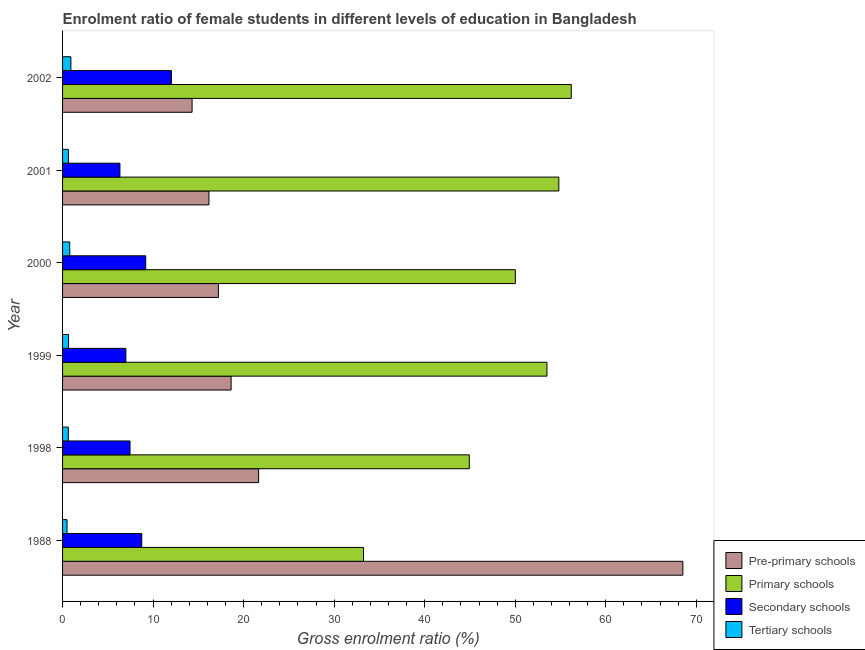How many different coloured bars are there?
Ensure brevity in your answer.  4. How many groups of bars are there?
Your answer should be very brief. 6. Are the number of bars per tick equal to the number of legend labels?
Provide a short and direct response. Yes. What is the label of the 1st group of bars from the top?
Offer a very short reply. 2002. In how many cases, is the number of bars for a given year not equal to the number of legend labels?
Make the answer very short. 0. What is the gross enrolment ratio(male) in secondary schools in 2002?
Give a very brief answer. 12.02. Across all years, what is the maximum gross enrolment ratio(male) in primary schools?
Your answer should be compact. 56.19. Across all years, what is the minimum gross enrolment ratio(male) in primary schools?
Ensure brevity in your answer.  33.24. In which year was the gross enrolment ratio(male) in pre-primary schools minimum?
Keep it short and to the point. 2002. What is the total gross enrolment ratio(male) in tertiary schools in the graph?
Make the answer very short. 4.15. What is the difference between the gross enrolment ratio(male) in secondary schools in 2000 and that in 2001?
Offer a terse response. 2.85. What is the difference between the gross enrolment ratio(male) in tertiary schools in 1988 and the gross enrolment ratio(male) in pre-primary schools in 1998?
Ensure brevity in your answer.  -21.16. What is the average gross enrolment ratio(male) in secondary schools per year?
Ensure brevity in your answer.  8.46. In the year 2000, what is the difference between the gross enrolment ratio(male) in secondary schools and gross enrolment ratio(male) in tertiary schools?
Provide a succinct answer. 8.39. What is the ratio of the gross enrolment ratio(male) in primary schools in 1988 to that in 1998?
Your answer should be very brief. 0.74. Is the gross enrolment ratio(male) in primary schools in 1999 less than that in 2002?
Keep it short and to the point. Yes. Is the difference between the gross enrolment ratio(male) in pre-primary schools in 1998 and 2000 greater than the difference between the gross enrolment ratio(male) in secondary schools in 1998 and 2000?
Make the answer very short. Yes. What is the difference between the highest and the second highest gross enrolment ratio(male) in tertiary schools?
Provide a succinct answer. 0.13. What is the difference between the highest and the lowest gross enrolment ratio(male) in tertiary schools?
Provide a short and direct response. 0.43. In how many years, is the gross enrolment ratio(male) in secondary schools greater than the average gross enrolment ratio(male) in secondary schools taken over all years?
Make the answer very short. 3. Is the sum of the gross enrolment ratio(male) in tertiary schools in 2000 and 2002 greater than the maximum gross enrolment ratio(male) in primary schools across all years?
Provide a short and direct response. No. Is it the case that in every year, the sum of the gross enrolment ratio(male) in tertiary schools and gross enrolment ratio(male) in pre-primary schools is greater than the sum of gross enrolment ratio(male) in secondary schools and gross enrolment ratio(male) in primary schools?
Offer a terse response. No. What does the 2nd bar from the top in 2002 represents?
Give a very brief answer. Secondary schools. What does the 1st bar from the bottom in 1988 represents?
Your answer should be very brief. Pre-primary schools. How many bars are there?
Provide a short and direct response. 24. Are all the bars in the graph horizontal?
Give a very brief answer. Yes. How many years are there in the graph?
Give a very brief answer. 6. What is the difference between two consecutive major ticks on the X-axis?
Provide a succinct answer. 10. Are the values on the major ticks of X-axis written in scientific E-notation?
Offer a terse response. No. Where does the legend appear in the graph?
Offer a terse response. Bottom right. How are the legend labels stacked?
Ensure brevity in your answer.  Vertical. What is the title of the graph?
Your response must be concise. Enrolment ratio of female students in different levels of education in Bangladesh. Does "Insurance services" appear as one of the legend labels in the graph?
Make the answer very short. No. What is the Gross enrolment ratio (%) of Pre-primary schools in 1988?
Make the answer very short. 68.52. What is the Gross enrolment ratio (%) in Primary schools in 1988?
Ensure brevity in your answer.  33.24. What is the Gross enrolment ratio (%) of Secondary schools in 1988?
Ensure brevity in your answer.  8.74. What is the Gross enrolment ratio (%) in Tertiary schools in 1988?
Give a very brief answer. 0.49. What is the Gross enrolment ratio (%) in Pre-primary schools in 1998?
Your answer should be compact. 21.66. What is the Gross enrolment ratio (%) in Primary schools in 1998?
Offer a terse response. 44.93. What is the Gross enrolment ratio (%) in Secondary schools in 1998?
Your answer should be compact. 7.45. What is the Gross enrolment ratio (%) in Tertiary schools in 1998?
Provide a short and direct response. 0.64. What is the Gross enrolment ratio (%) of Pre-primary schools in 1999?
Give a very brief answer. 18.62. What is the Gross enrolment ratio (%) of Primary schools in 1999?
Provide a short and direct response. 53.5. What is the Gross enrolment ratio (%) of Secondary schools in 1999?
Offer a very short reply. 6.99. What is the Gross enrolment ratio (%) in Tertiary schools in 1999?
Your response must be concise. 0.66. What is the Gross enrolment ratio (%) of Pre-primary schools in 2000?
Make the answer very short. 17.21. What is the Gross enrolment ratio (%) in Primary schools in 2000?
Make the answer very short. 50.01. What is the Gross enrolment ratio (%) in Secondary schools in 2000?
Provide a short and direct response. 9.18. What is the Gross enrolment ratio (%) in Tertiary schools in 2000?
Provide a short and direct response. 0.79. What is the Gross enrolment ratio (%) of Pre-primary schools in 2001?
Your answer should be very brief. 16.17. What is the Gross enrolment ratio (%) in Primary schools in 2001?
Provide a succinct answer. 54.82. What is the Gross enrolment ratio (%) of Secondary schools in 2001?
Give a very brief answer. 6.34. What is the Gross enrolment ratio (%) in Tertiary schools in 2001?
Offer a terse response. 0.65. What is the Gross enrolment ratio (%) of Pre-primary schools in 2002?
Offer a terse response. 14.31. What is the Gross enrolment ratio (%) in Primary schools in 2002?
Ensure brevity in your answer.  56.19. What is the Gross enrolment ratio (%) of Secondary schools in 2002?
Keep it short and to the point. 12.02. What is the Gross enrolment ratio (%) of Tertiary schools in 2002?
Your answer should be very brief. 0.92. Across all years, what is the maximum Gross enrolment ratio (%) in Pre-primary schools?
Make the answer very short. 68.52. Across all years, what is the maximum Gross enrolment ratio (%) in Primary schools?
Offer a very short reply. 56.19. Across all years, what is the maximum Gross enrolment ratio (%) of Secondary schools?
Ensure brevity in your answer.  12.02. Across all years, what is the maximum Gross enrolment ratio (%) in Tertiary schools?
Give a very brief answer. 0.92. Across all years, what is the minimum Gross enrolment ratio (%) of Pre-primary schools?
Keep it short and to the point. 14.31. Across all years, what is the minimum Gross enrolment ratio (%) of Primary schools?
Keep it short and to the point. 33.24. Across all years, what is the minimum Gross enrolment ratio (%) of Secondary schools?
Offer a terse response. 6.34. Across all years, what is the minimum Gross enrolment ratio (%) of Tertiary schools?
Give a very brief answer. 0.49. What is the total Gross enrolment ratio (%) in Pre-primary schools in the graph?
Keep it short and to the point. 156.48. What is the total Gross enrolment ratio (%) in Primary schools in the graph?
Provide a succinct answer. 292.7. What is the total Gross enrolment ratio (%) in Secondary schools in the graph?
Give a very brief answer. 50.73. What is the total Gross enrolment ratio (%) in Tertiary schools in the graph?
Offer a very short reply. 4.15. What is the difference between the Gross enrolment ratio (%) in Pre-primary schools in 1988 and that in 1998?
Provide a short and direct response. 46.86. What is the difference between the Gross enrolment ratio (%) of Primary schools in 1988 and that in 1998?
Your answer should be compact. -11.69. What is the difference between the Gross enrolment ratio (%) in Secondary schools in 1988 and that in 1998?
Your answer should be very brief. 1.29. What is the difference between the Gross enrolment ratio (%) in Tertiary schools in 1988 and that in 1998?
Offer a very short reply. -0.14. What is the difference between the Gross enrolment ratio (%) of Pre-primary schools in 1988 and that in 1999?
Give a very brief answer. 49.9. What is the difference between the Gross enrolment ratio (%) in Primary schools in 1988 and that in 1999?
Provide a short and direct response. -20.26. What is the difference between the Gross enrolment ratio (%) of Secondary schools in 1988 and that in 1999?
Keep it short and to the point. 1.75. What is the difference between the Gross enrolment ratio (%) in Tertiary schools in 1988 and that in 1999?
Your answer should be compact. -0.17. What is the difference between the Gross enrolment ratio (%) of Pre-primary schools in 1988 and that in 2000?
Offer a terse response. 51.31. What is the difference between the Gross enrolment ratio (%) in Primary schools in 1988 and that in 2000?
Your response must be concise. -16.77. What is the difference between the Gross enrolment ratio (%) of Secondary schools in 1988 and that in 2000?
Keep it short and to the point. -0.44. What is the difference between the Gross enrolment ratio (%) of Tertiary schools in 1988 and that in 2000?
Your answer should be compact. -0.3. What is the difference between the Gross enrolment ratio (%) of Pre-primary schools in 1988 and that in 2001?
Ensure brevity in your answer.  52.35. What is the difference between the Gross enrolment ratio (%) in Primary schools in 1988 and that in 2001?
Make the answer very short. -21.57. What is the difference between the Gross enrolment ratio (%) in Secondary schools in 1988 and that in 2001?
Keep it short and to the point. 2.41. What is the difference between the Gross enrolment ratio (%) in Tertiary schools in 1988 and that in 2001?
Offer a very short reply. -0.15. What is the difference between the Gross enrolment ratio (%) of Pre-primary schools in 1988 and that in 2002?
Ensure brevity in your answer.  54.21. What is the difference between the Gross enrolment ratio (%) in Primary schools in 1988 and that in 2002?
Your answer should be very brief. -22.95. What is the difference between the Gross enrolment ratio (%) of Secondary schools in 1988 and that in 2002?
Offer a very short reply. -3.28. What is the difference between the Gross enrolment ratio (%) in Tertiary schools in 1988 and that in 2002?
Keep it short and to the point. -0.43. What is the difference between the Gross enrolment ratio (%) of Pre-primary schools in 1998 and that in 1999?
Offer a terse response. 3.04. What is the difference between the Gross enrolment ratio (%) of Primary schools in 1998 and that in 1999?
Provide a succinct answer. -8.57. What is the difference between the Gross enrolment ratio (%) of Secondary schools in 1998 and that in 1999?
Make the answer very short. 0.46. What is the difference between the Gross enrolment ratio (%) of Tertiary schools in 1998 and that in 1999?
Offer a very short reply. -0.03. What is the difference between the Gross enrolment ratio (%) in Pre-primary schools in 1998 and that in 2000?
Keep it short and to the point. 4.44. What is the difference between the Gross enrolment ratio (%) of Primary schools in 1998 and that in 2000?
Offer a terse response. -5.08. What is the difference between the Gross enrolment ratio (%) of Secondary schools in 1998 and that in 2000?
Make the answer very short. -1.73. What is the difference between the Gross enrolment ratio (%) of Tertiary schools in 1998 and that in 2000?
Offer a terse response. -0.16. What is the difference between the Gross enrolment ratio (%) of Pre-primary schools in 1998 and that in 2001?
Keep it short and to the point. 5.49. What is the difference between the Gross enrolment ratio (%) of Primary schools in 1998 and that in 2001?
Offer a very short reply. -9.89. What is the difference between the Gross enrolment ratio (%) of Secondary schools in 1998 and that in 2001?
Offer a terse response. 1.12. What is the difference between the Gross enrolment ratio (%) of Tertiary schools in 1998 and that in 2001?
Make the answer very short. -0.01. What is the difference between the Gross enrolment ratio (%) in Pre-primary schools in 1998 and that in 2002?
Your response must be concise. 7.35. What is the difference between the Gross enrolment ratio (%) in Primary schools in 1998 and that in 2002?
Keep it short and to the point. -11.26. What is the difference between the Gross enrolment ratio (%) of Secondary schools in 1998 and that in 2002?
Give a very brief answer. -4.57. What is the difference between the Gross enrolment ratio (%) of Tertiary schools in 1998 and that in 2002?
Your answer should be very brief. -0.28. What is the difference between the Gross enrolment ratio (%) in Pre-primary schools in 1999 and that in 2000?
Your answer should be very brief. 1.4. What is the difference between the Gross enrolment ratio (%) of Primary schools in 1999 and that in 2000?
Keep it short and to the point. 3.49. What is the difference between the Gross enrolment ratio (%) in Secondary schools in 1999 and that in 2000?
Ensure brevity in your answer.  -2.19. What is the difference between the Gross enrolment ratio (%) in Tertiary schools in 1999 and that in 2000?
Provide a succinct answer. -0.13. What is the difference between the Gross enrolment ratio (%) in Pre-primary schools in 1999 and that in 2001?
Make the answer very short. 2.45. What is the difference between the Gross enrolment ratio (%) of Primary schools in 1999 and that in 2001?
Your answer should be compact. -1.31. What is the difference between the Gross enrolment ratio (%) in Secondary schools in 1999 and that in 2001?
Give a very brief answer. 0.65. What is the difference between the Gross enrolment ratio (%) in Tertiary schools in 1999 and that in 2001?
Keep it short and to the point. 0.02. What is the difference between the Gross enrolment ratio (%) in Pre-primary schools in 1999 and that in 2002?
Offer a very short reply. 4.31. What is the difference between the Gross enrolment ratio (%) in Primary schools in 1999 and that in 2002?
Your answer should be very brief. -2.69. What is the difference between the Gross enrolment ratio (%) of Secondary schools in 1999 and that in 2002?
Provide a succinct answer. -5.03. What is the difference between the Gross enrolment ratio (%) of Tertiary schools in 1999 and that in 2002?
Offer a terse response. -0.26. What is the difference between the Gross enrolment ratio (%) in Pre-primary schools in 2000 and that in 2001?
Provide a succinct answer. 1.04. What is the difference between the Gross enrolment ratio (%) of Primary schools in 2000 and that in 2001?
Ensure brevity in your answer.  -4.8. What is the difference between the Gross enrolment ratio (%) in Secondary schools in 2000 and that in 2001?
Provide a short and direct response. 2.85. What is the difference between the Gross enrolment ratio (%) of Tertiary schools in 2000 and that in 2001?
Make the answer very short. 0.15. What is the difference between the Gross enrolment ratio (%) of Pre-primary schools in 2000 and that in 2002?
Your response must be concise. 2.91. What is the difference between the Gross enrolment ratio (%) in Primary schools in 2000 and that in 2002?
Offer a very short reply. -6.18. What is the difference between the Gross enrolment ratio (%) of Secondary schools in 2000 and that in 2002?
Your answer should be very brief. -2.84. What is the difference between the Gross enrolment ratio (%) of Tertiary schools in 2000 and that in 2002?
Your answer should be compact. -0.13. What is the difference between the Gross enrolment ratio (%) of Pre-primary schools in 2001 and that in 2002?
Your response must be concise. 1.86. What is the difference between the Gross enrolment ratio (%) of Primary schools in 2001 and that in 2002?
Give a very brief answer. -1.37. What is the difference between the Gross enrolment ratio (%) in Secondary schools in 2001 and that in 2002?
Keep it short and to the point. -5.69. What is the difference between the Gross enrolment ratio (%) in Tertiary schools in 2001 and that in 2002?
Your answer should be very brief. -0.27. What is the difference between the Gross enrolment ratio (%) of Pre-primary schools in 1988 and the Gross enrolment ratio (%) of Primary schools in 1998?
Ensure brevity in your answer.  23.59. What is the difference between the Gross enrolment ratio (%) of Pre-primary schools in 1988 and the Gross enrolment ratio (%) of Secondary schools in 1998?
Keep it short and to the point. 61.07. What is the difference between the Gross enrolment ratio (%) in Pre-primary schools in 1988 and the Gross enrolment ratio (%) in Tertiary schools in 1998?
Provide a succinct answer. 67.88. What is the difference between the Gross enrolment ratio (%) in Primary schools in 1988 and the Gross enrolment ratio (%) in Secondary schools in 1998?
Make the answer very short. 25.79. What is the difference between the Gross enrolment ratio (%) in Primary schools in 1988 and the Gross enrolment ratio (%) in Tertiary schools in 1998?
Offer a very short reply. 32.61. What is the difference between the Gross enrolment ratio (%) in Secondary schools in 1988 and the Gross enrolment ratio (%) in Tertiary schools in 1998?
Ensure brevity in your answer.  8.11. What is the difference between the Gross enrolment ratio (%) in Pre-primary schools in 1988 and the Gross enrolment ratio (%) in Primary schools in 1999?
Make the answer very short. 15.02. What is the difference between the Gross enrolment ratio (%) in Pre-primary schools in 1988 and the Gross enrolment ratio (%) in Secondary schools in 1999?
Provide a short and direct response. 61.53. What is the difference between the Gross enrolment ratio (%) in Pre-primary schools in 1988 and the Gross enrolment ratio (%) in Tertiary schools in 1999?
Offer a terse response. 67.86. What is the difference between the Gross enrolment ratio (%) in Primary schools in 1988 and the Gross enrolment ratio (%) in Secondary schools in 1999?
Give a very brief answer. 26.25. What is the difference between the Gross enrolment ratio (%) of Primary schools in 1988 and the Gross enrolment ratio (%) of Tertiary schools in 1999?
Ensure brevity in your answer.  32.58. What is the difference between the Gross enrolment ratio (%) of Secondary schools in 1988 and the Gross enrolment ratio (%) of Tertiary schools in 1999?
Offer a terse response. 8.08. What is the difference between the Gross enrolment ratio (%) in Pre-primary schools in 1988 and the Gross enrolment ratio (%) in Primary schools in 2000?
Keep it short and to the point. 18.51. What is the difference between the Gross enrolment ratio (%) of Pre-primary schools in 1988 and the Gross enrolment ratio (%) of Secondary schools in 2000?
Provide a short and direct response. 59.34. What is the difference between the Gross enrolment ratio (%) of Pre-primary schools in 1988 and the Gross enrolment ratio (%) of Tertiary schools in 2000?
Offer a terse response. 67.73. What is the difference between the Gross enrolment ratio (%) in Primary schools in 1988 and the Gross enrolment ratio (%) in Secondary schools in 2000?
Provide a short and direct response. 24.06. What is the difference between the Gross enrolment ratio (%) in Primary schools in 1988 and the Gross enrolment ratio (%) in Tertiary schools in 2000?
Give a very brief answer. 32.45. What is the difference between the Gross enrolment ratio (%) of Secondary schools in 1988 and the Gross enrolment ratio (%) of Tertiary schools in 2000?
Your answer should be compact. 7.95. What is the difference between the Gross enrolment ratio (%) in Pre-primary schools in 1988 and the Gross enrolment ratio (%) in Primary schools in 2001?
Keep it short and to the point. 13.7. What is the difference between the Gross enrolment ratio (%) in Pre-primary schools in 1988 and the Gross enrolment ratio (%) in Secondary schools in 2001?
Your answer should be very brief. 62.18. What is the difference between the Gross enrolment ratio (%) in Pre-primary schools in 1988 and the Gross enrolment ratio (%) in Tertiary schools in 2001?
Ensure brevity in your answer.  67.87. What is the difference between the Gross enrolment ratio (%) of Primary schools in 1988 and the Gross enrolment ratio (%) of Secondary schools in 2001?
Provide a succinct answer. 26.91. What is the difference between the Gross enrolment ratio (%) in Primary schools in 1988 and the Gross enrolment ratio (%) in Tertiary schools in 2001?
Offer a very short reply. 32.6. What is the difference between the Gross enrolment ratio (%) in Secondary schools in 1988 and the Gross enrolment ratio (%) in Tertiary schools in 2001?
Your response must be concise. 8.1. What is the difference between the Gross enrolment ratio (%) in Pre-primary schools in 1988 and the Gross enrolment ratio (%) in Primary schools in 2002?
Your answer should be compact. 12.33. What is the difference between the Gross enrolment ratio (%) in Pre-primary schools in 1988 and the Gross enrolment ratio (%) in Secondary schools in 2002?
Make the answer very short. 56.5. What is the difference between the Gross enrolment ratio (%) of Pre-primary schools in 1988 and the Gross enrolment ratio (%) of Tertiary schools in 2002?
Offer a very short reply. 67.6. What is the difference between the Gross enrolment ratio (%) in Primary schools in 1988 and the Gross enrolment ratio (%) in Secondary schools in 2002?
Ensure brevity in your answer.  21.22. What is the difference between the Gross enrolment ratio (%) of Primary schools in 1988 and the Gross enrolment ratio (%) of Tertiary schools in 2002?
Make the answer very short. 32.32. What is the difference between the Gross enrolment ratio (%) of Secondary schools in 1988 and the Gross enrolment ratio (%) of Tertiary schools in 2002?
Provide a short and direct response. 7.82. What is the difference between the Gross enrolment ratio (%) in Pre-primary schools in 1998 and the Gross enrolment ratio (%) in Primary schools in 1999?
Your answer should be compact. -31.85. What is the difference between the Gross enrolment ratio (%) of Pre-primary schools in 1998 and the Gross enrolment ratio (%) of Secondary schools in 1999?
Your answer should be very brief. 14.67. What is the difference between the Gross enrolment ratio (%) in Pre-primary schools in 1998 and the Gross enrolment ratio (%) in Tertiary schools in 1999?
Provide a short and direct response. 20.99. What is the difference between the Gross enrolment ratio (%) of Primary schools in 1998 and the Gross enrolment ratio (%) of Secondary schools in 1999?
Provide a succinct answer. 37.94. What is the difference between the Gross enrolment ratio (%) of Primary schools in 1998 and the Gross enrolment ratio (%) of Tertiary schools in 1999?
Make the answer very short. 44.27. What is the difference between the Gross enrolment ratio (%) of Secondary schools in 1998 and the Gross enrolment ratio (%) of Tertiary schools in 1999?
Your response must be concise. 6.79. What is the difference between the Gross enrolment ratio (%) in Pre-primary schools in 1998 and the Gross enrolment ratio (%) in Primary schools in 2000?
Provide a short and direct response. -28.36. What is the difference between the Gross enrolment ratio (%) in Pre-primary schools in 1998 and the Gross enrolment ratio (%) in Secondary schools in 2000?
Ensure brevity in your answer.  12.47. What is the difference between the Gross enrolment ratio (%) of Pre-primary schools in 1998 and the Gross enrolment ratio (%) of Tertiary schools in 2000?
Ensure brevity in your answer.  20.87. What is the difference between the Gross enrolment ratio (%) in Primary schools in 1998 and the Gross enrolment ratio (%) in Secondary schools in 2000?
Give a very brief answer. 35.75. What is the difference between the Gross enrolment ratio (%) of Primary schools in 1998 and the Gross enrolment ratio (%) of Tertiary schools in 2000?
Ensure brevity in your answer.  44.14. What is the difference between the Gross enrolment ratio (%) in Secondary schools in 1998 and the Gross enrolment ratio (%) in Tertiary schools in 2000?
Give a very brief answer. 6.66. What is the difference between the Gross enrolment ratio (%) in Pre-primary schools in 1998 and the Gross enrolment ratio (%) in Primary schools in 2001?
Ensure brevity in your answer.  -33.16. What is the difference between the Gross enrolment ratio (%) of Pre-primary schools in 1998 and the Gross enrolment ratio (%) of Secondary schools in 2001?
Your answer should be compact. 15.32. What is the difference between the Gross enrolment ratio (%) of Pre-primary schools in 1998 and the Gross enrolment ratio (%) of Tertiary schools in 2001?
Your response must be concise. 21.01. What is the difference between the Gross enrolment ratio (%) of Primary schools in 1998 and the Gross enrolment ratio (%) of Secondary schools in 2001?
Your response must be concise. 38.59. What is the difference between the Gross enrolment ratio (%) in Primary schools in 1998 and the Gross enrolment ratio (%) in Tertiary schools in 2001?
Provide a short and direct response. 44.28. What is the difference between the Gross enrolment ratio (%) in Secondary schools in 1998 and the Gross enrolment ratio (%) in Tertiary schools in 2001?
Offer a terse response. 6.81. What is the difference between the Gross enrolment ratio (%) of Pre-primary schools in 1998 and the Gross enrolment ratio (%) of Primary schools in 2002?
Ensure brevity in your answer.  -34.54. What is the difference between the Gross enrolment ratio (%) of Pre-primary schools in 1998 and the Gross enrolment ratio (%) of Secondary schools in 2002?
Your response must be concise. 9.63. What is the difference between the Gross enrolment ratio (%) in Pre-primary schools in 1998 and the Gross enrolment ratio (%) in Tertiary schools in 2002?
Give a very brief answer. 20.74. What is the difference between the Gross enrolment ratio (%) in Primary schools in 1998 and the Gross enrolment ratio (%) in Secondary schools in 2002?
Keep it short and to the point. 32.91. What is the difference between the Gross enrolment ratio (%) in Primary schools in 1998 and the Gross enrolment ratio (%) in Tertiary schools in 2002?
Keep it short and to the point. 44.01. What is the difference between the Gross enrolment ratio (%) in Secondary schools in 1998 and the Gross enrolment ratio (%) in Tertiary schools in 2002?
Make the answer very short. 6.53. What is the difference between the Gross enrolment ratio (%) of Pre-primary schools in 1999 and the Gross enrolment ratio (%) of Primary schools in 2000?
Your answer should be compact. -31.4. What is the difference between the Gross enrolment ratio (%) in Pre-primary schools in 1999 and the Gross enrolment ratio (%) in Secondary schools in 2000?
Make the answer very short. 9.43. What is the difference between the Gross enrolment ratio (%) in Pre-primary schools in 1999 and the Gross enrolment ratio (%) in Tertiary schools in 2000?
Offer a terse response. 17.83. What is the difference between the Gross enrolment ratio (%) of Primary schools in 1999 and the Gross enrolment ratio (%) of Secondary schools in 2000?
Provide a succinct answer. 44.32. What is the difference between the Gross enrolment ratio (%) of Primary schools in 1999 and the Gross enrolment ratio (%) of Tertiary schools in 2000?
Make the answer very short. 52.71. What is the difference between the Gross enrolment ratio (%) of Secondary schools in 1999 and the Gross enrolment ratio (%) of Tertiary schools in 2000?
Provide a succinct answer. 6.2. What is the difference between the Gross enrolment ratio (%) in Pre-primary schools in 1999 and the Gross enrolment ratio (%) in Primary schools in 2001?
Offer a very short reply. -36.2. What is the difference between the Gross enrolment ratio (%) of Pre-primary schools in 1999 and the Gross enrolment ratio (%) of Secondary schools in 2001?
Give a very brief answer. 12.28. What is the difference between the Gross enrolment ratio (%) of Pre-primary schools in 1999 and the Gross enrolment ratio (%) of Tertiary schools in 2001?
Offer a terse response. 17.97. What is the difference between the Gross enrolment ratio (%) in Primary schools in 1999 and the Gross enrolment ratio (%) in Secondary schools in 2001?
Your answer should be very brief. 47.17. What is the difference between the Gross enrolment ratio (%) of Primary schools in 1999 and the Gross enrolment ratio (%) of Tertiary schools in 2001?
Keep it short and to the point. 52.86. What is the difference between the Gross enrolment ratio (%) in Secondary schools in 1999 and the Gross enrolment ratio (%) in Tertiary schools in 2001?
Offer a terse response. 6.34. What is the difference between the Gross enrolment ratio (%) in Pre-primary schools in 1999 and the Gross enrolment ratio (%) in Primary schools in 2002?
Keep it short and to the point. -37.57. What is the difference between the Gross enrolment ratio (%) of Pre-primary schools in 1999 and the Gross enrolment ratio (%) of Secondary schools in 2002?
Your answer should be very brief. 6.6. What is the difference between the Gross enrolment ratio (%) in Pre-primary schools in 1999 and the Gross enrolment ratio (%) in Tertiary schools in 2002?
Make the answer very short. 17.7. What is the difference between the Gross enrolment ratio (%) of Primary schools in 1999 and the Gross enrolment ratio (%) of Secondary schools in 2002?
Offer a terse response. 41.48. What is the difference between the Gross enrolment ratio (%) of Primary schools in 1999 and the Gross enrolment ratio (%) of Tertiary schools in 2002?
Keep it short and to the point. 52.58. What is the difference between the Gross enrolment ratio (%) in Secondary schools in 1999 and the Gross enrolment ratio (%) in Tertiary schools in 2002?
Offer a terse response. 6.07. What is the difference between the Gross enrolment ratio (%) in Pre-primary schools in 2000 and the Gross enrolment ratio (%) in Primary schools in 2001?
Offer a terse response. -37.6. What is the difference between the Gross enrolment ratio (%) in Pre-primary schools in 2000 and the Gross enrolment ratio (%) in Secondary schools in 2001?
Keep it short and to the point. 10.88. What is the difference between the Gross enrolment ratio (%) in Pre-primary schools in 2000 and the Gross enrolment ratio (%) in Tertiary schools in 2001?
Provide a short and direct response. 16.57. What is the difference between the Gross enrolment ratio (%) in Primary schools in 2000 and the Gross enrolment ratio (%) in Secondary schools in 2001?
Offer a terse response. 43.68. What is the difference between the Gross enrolment ratio (%) of Primary schools in 2000 and the Gross enrolment ratio (%) of Tertiary schools in 2001?
Your answer should be very brief. 49.37. What is the difference between the Gross enrolment ratio (%) of Secondary schools in 2000 and the Gross enrolment ratio (%) of Tertiary schools in 2001?
Provide a short and direct response. 8.54. What is the difference between the Gross enrolment ratio (%) in Pre-primary schools in 2000 and the Gross enrolment ratio (%) in Primary schools in 2002?
Ensure brevity in your answer.  -38.98. What is the difference between the Gross enrolment ratio (%) in Pre-primary schools in 2000 and the Gross enrolment ratio (%) in Secondary schools in 2002?
Offer a very short reply. 5.19. What is the difference between the Gross enrolment ratio (%) in Pre-primary schools in 2000 and the Gross enrolment ratio (%) in Tertiary schools in 2002?
Provide a succinct answer. 16.29. What is the difference between the Gross enrolment ratio (%) in Primary schools in 2000 and the Gross enrolment ratio (%) in Secondary schools in 2002?
Keep it short and to the point. 37.99. What is the difference between the Gross enrolment ratio (%) in Primary schools in 2000 and the Gross enrolment ratio (%) in Tertiary schools in 2002?
Your answer should be very brief. 49.09. What is the difference between the Gross enrolment ratio (%) of Secondary schools in 2000 and the Gross enrolment ratio (%) of Tertiary schools in 2002?
Your response must be concise. 8.26. What is the difference between the Gross enrolment ratio (%) of Pre-primary schools in 2001 and the Gross enrolment ratio (%) of Primary schools in 2002?
Ensure brevity in your answer.  -40.02. What is the difference between the Gross enrolment ratio (%) in Pre-primary schools in 2001 and the Gross enrolment ratio (%) in Secondary schools in 2002?
Give a very brief answer. 4.15. What is the difference between the Gross enrolment ratio (%) in Pre-primary schools in 2001 and the Gross enrolment ratio (%) in Tertiary schools in 2002?
Give a very brief answer. 15.25. What is the difference between the Gross enrolment ratio (%) of Primary schools in 2001 and the Gross enrolment ratio (%) of Secondary schools in 2002?
Your answer should be very brief. 42.79. What is the difference between the Gross enrolment ratio (%) in Primary schools in 2001 and the Gross enrolment ratio (%) in Tertiary schools in 2002?
Provide a short and direct response. 53.9. What is the difference between the Gross enrolment ratio (%) in Secondary schools in 2001 and the Gross enrolment ratio (%) in Tertiary schools in 2002?
Offer a very short reply. 5.42. What is the average Gross enrolment ratio (%) in Pre-primary schools per year?
Offer a terse response. 26.08. What is the average Gross enrolment ratio (%) in Primary schools per year?
Your answer should be very brief. 48.78. What is the average Gross enrolment ratio (%) of Secondary schools per year?
Offer a terse response. 8.45. What is the average Gross enrolment ratio (%) of Tertiary schools per year?
Your answer should be compact. 0.69. In the year 1988, what is the difference between the Gross enrolment ratio (%) in Pre-primary schools and Gross enrolment ratio (%) in Primary schools?
Offer a very short reply. 35.28. In the year 1988, what is the difference between the Gross enrolment ratio (%) of Pre-primary schools and Gross enrolment ratio (%) of Secondary schools?
Your answer should be compact. 59.78. In the year 1988, what is the difference between the Gross enrolment ratio (%) of Pre-primary schools and Gross enrolment ratio (%) of Tertiary schools?
Your response must be concise. 68.03. In the year 1988, what is the difference between the Gross enrolment ratio (%) in Primary schools and Gross enrolment ratio (%) in Secondary schools?
Provide a succinct answer. 24.5. In the year 1988, what is the difference between the Gross enrolment ratio (%) in Primary schools and Gross enrolment ratio (%) in Tertiary schools?
Provide a short and direct response. 32.75. In the year 1988, what is the difference between the Gross enrolment ratio (%) of Secondary schools and Gross enrolment ratio (%) of Tertiary schools?
Offer a terse response. 8.25. In the year 1998, what is the difference between the Gross enrolment ratio (%) of Pre-primary schools and Gross enrolment ratio (%) of Primary schools?
Keep it short and to the point. -23.27. In the year 1998, what is the difference between the Gross enrolment ratio (%) in Pre-primary schools and Gross enrolment ratio (%) in Secondary schools?
Your answer should be compact. 14.2. In the year 1998, what is the difference between the Gross enrolment ratio (%) in Pre-primary schools and Gross enrolment ratio (%) in Tertiary schools?
Offer a terse response. 21.02. In the year 1998, what is the difference between the Gross enrolment ratio (%) of Primary schools and Gross enrolment ratio (%) of Secondary schools?
Provide a short and direct response. 37.48. In the year 1998, what is the difference between the Gross enrolment ratio (%) in Primary schools and Gross enrolment ratio (%) in Tertiary schools?
Your answer should be very brief. 44.29. In the year 1998, what is the difference between the Gross enrolment ratio (%) in Secondary schools and Gross enrolment ratio (%) in Tertiary schools?
Offer a very short reply. 6.82. In the year 1999, what is the difference between the Gross enrolment ratio (%) of Pre-primary schools and Gross enrolment ratio (%) of Primary schools?
Keep it short and to the point. -34.88. In the year 1999, what is the difference between the Gross enrolment ratio (%) of Pre-primary schools and Gross enrolment ratio (%) of Secondary schools?
Ensure brevity in your answer.  11.63. In the year 1999, what is the difference between the Gross enrolment ratio (%) in Pre-primary schools and Gross enrolment ratio (%) in Tertiary schools?
Offer a terse response. 17.96. In the year 1999, what is the difference between the Gross enrolment ratio (%) of Primary schools and Gross enrolment ratio (%) of Secondary schools?
Your answer should be very brief. 46.51. In the year 1999, what is the difference between the Gross enrolment ratio (%) of Primary schools and Gross enrolment ratio (%) of Tertiary schools?
Offer a terse response. 52.84. In the year 1999, what is the difference between the Gross enrolment ratio (%) of Secondary schools and Gross enrolment ratio (%) of Tertiary schools?
Offer a terse response. 6.33. In the year 2000, what is the difference between the Gross enrolment ratio (%) of Pre-primary schools and Gross enrolment ratio (%) of Primary schools?
Your answer should be very brief. -32.8. In the year 2000, what is the difference between the Gross enrolment ratio (%) in Pre-primary schools and Gross enrolment ratio (%) in Secondary schools?
Your answer should be compact. 8.03. In the year 2000, what is the difference between the Gross enrolment ratio (%) of Pre-primary schools and Gross enrolment ratio (%) of Tertiary schools?
Provide a short and direct response. 16.42. In the year 2000, what is the difference between the Gross enrolment ratio (%) of Primary schools and Gross enrolment ratio (%) of Secondary schools?
Your answer should be very brief. 40.83. In the year 2000, what is the difference between the Gross enrolment ratio (%) in Primary schools and Gross enrolment ratio (%) in Tertiary schools?
Your response must be concise. 49.22. In the year 2000, what is the difference between the Gross enrolment ratio (%) in Secondary schools and Gross enrolment ratio (%) in Tertiary schools?
Keep it short and to the point. 8.39. In the year 2001, what is the difference between the Gross enrolment ratio (%) of Pre-primary schools and Gross enrolment ratio (%) of Primary schools?
Give a very brief answer. -38.65. In the year 2001, what is the difference between the Gross enrolment ratio (%) of Pre-primary schools and Gross enrolment ratio (%) of Secondary schools?
Your response must be concise. 9.83. In the year 2001, what is the difference between the Gross enrolment ratio (%) of Pre-primary schools and Gross enrolment ratio (%) of Tertiary schools?
Your answer should be very brief. 15.52. In the year 2001, what is the difference between the Gross enrolment ratio (%) of Primary schools and Gross enrolment ratio (%) of Secondary schools?
Make the answer very short. 48.48. In the year 2001, what is the difference between the Gross enrolment ratio (%) of Primary schools and Gross enrolment ratio (%) of Tertiary schools?
Offer a terse response. 54.17. In the year 2001, what is the difference between the Gross enrolment ratio (%) of Secondary schools and Gross enrolment ratio (%) of Tertiary schools?
Provide a short and direct response. 5.69. In the year 2002, what is the difference between the Gross enrolment ratio (%) in Pre-primary schools and Gross enrolment ratio (%) in Primary schools?
Give a very brief answer. -41.88. In the year 2002, what is the difference between the Gross enrolment ratio (%) of Pre-primary schools and Gross enrolment ratio (%) of Secondary schools?
Your answer should be very brief. 2.28. In the year 2002, what is the difference between the Gross enrolment ratio (%) in Pre-primary schools and Gross enrolment ratio (%) in Tertiary schools?
Provide a short and direct response. 13.39. In the year 2002, what is the difference between the Gross enrolment ratio (%) in Primary schools and Gross enrolment ratio (%) in Secondary schools?
Keep it short and to the point. 44.17. In the year 2002, what is the difference between the Gross enrolment ratio (%) in Primary schools and Gross enrolment ratio (%) in Tertiary schools?
Keep it short and to the point. 55.27. In the year 2002, what is the difference between the Gross enrolment ratio (%) of Secondary schools and Gross enrolment ratio (%) of Tertiary schools?
Provide a succinct answer. 11.1. What is the ratio of the Gross enrolment ratio (%) in Pre-primary schools in 1988 to that in 1998?
Provide a succinct answer. 3.16. What is the ratio of the Gross enrolment ratio (%) of Primary schools in 1988 to that in 1998?
Provide a succinct answer. 0.74. What is the ratio of the Gross enrolment ratio (%) of Secondary schools in 1988 to that in 1998?
Provide a short and direct response. 1.17. What is the ratio of the Gross enrolment ratio (%) in Tertiary schools in 1988 to that in 1998?
Offer a terse response. 0.78. What is the ratio of the Gross enrolment ratio (%) in Pre-primary schools in 1988 to that in 1999?
Give a very brief answer. 3.68. What is the ratio of the Gross enrolment ratio (%) in Primary schools in 1988 to that in 1999?
Keep it short and to the point. 0.62. What is the ratio of the Gross enrolment ratio (%) of Secondary schools in 1988 to that in 1999?
Your answer should be very brief. 1.25. What is the ratio of the Gross enrolment ratio (%) in Tertiary schools in 1988 to that in 1999?
Keep it short and to the point. 0.75. What is the ratio of the Gross enrolment ratio (%) in Pre-primary schools in 1988 to that in 2000?
Keep it short and to the point. 3.98. What is the ratio of the Gross enrolment ratio (%) in Primary schools in 1988 to that in 2000?
Your response must be concise. 0.66. What is the ratio of the Gross enrolment ratio (%) in Tertiary schools in 1988 to that in 2000?
Give a very brief answer. 0.62. What is the ratio of the Gross enrolment ratio (%) in Pre-primary schools in 1988 to that in 2001?
Offer a very short reply. 4.24. What is the ratio of the Gross enrolment ratio (%) of Primary schools in 1988 to that in 2001?
Keep it short and to the point. 0.61. What is the ratio of the Gross enrolment ratio (%) in Secondary schools in 1988 to that in 2001?
Keep it short and to the point. 1.38. What is the ratio of the Gross enrolment ratio (%) of Tertiary schools in 1988 to that in 2001?
Ensure brevity in your answer.  0.76. What is the ratio of the Gross enrolment ratio (%) of Pre-primary schools in 1988 to that in 2002?
Provide a short and direct response. 4.79. What is the ratio of the Gross enrolment ratio (%) in Primary schools in 1988 to that in 2002?
Provide a succinct answer. 0.59. What is the ratio of the Gross enrolment ratio (%) in Secondary schools in 1988 to that in 2002?
Give a very brief answer. 0.73. What is the ratio of the Gross enrolment ratio (%) in Tertiary schools in 1988 to that in 2002?
Give a very brief answer. 0.54. What is the ratio of the Gross enrolment ratio (%) of Pre-primary schools in 1998 to that in 1999?
Your response must be concise. 1.16. What is the ratio of the Gross enrolment ratio (%) in Primary schools in 1998 to that in 1999?
Your answer should be very brief. 0.84. What is the ratio of the Gross enrolment ratio (%) in Secondary schools in 1998 to that in 1999?
Keep it short and to the point. 1.07. What is the ratio of the Gross enrolment ratio (%) in Tertiary schools in 1998 to that in 1999?
Your response must be concise. 0.96. What is the ratio of the Gross enrolment ratio (%) of Pre-primary schools in 1998 to that in 2000?
Offer a very short reply. 1.26. What is the ratio of the Gross enrolment ratio (%) of Primary schools in 1998 to that in 2000?
Ensure brevity in your answer.  0.9. What is the ratio of the Gross enrolment ratio (%) of Secondary schools in 1998 to that in 2000?
Make the answer very short. 0.81. What is the ratio of the Gross enrolment ratio (%) of Tertiary schools in 1998 to that in 2000?
Your answer should be compact. 0.8. What is the ratio of the Gross enrolment ratio (%) in Pre-primary schools in 1998 to that in 2001?
Give a very brief answer. 1.34. What is the ratio of the Gross enrolment ratio (%) of Primary schools in 1998 to that in 2001?
Give a very brief answer. 0.82. What is the ratio of the Gross enrolment ratio (%) of Secondary schools in 1998 to that in 2001?
Your answer should be very brief. 1.18. What is the ratio of the Gross enrolment ratio (%) in Tertiary schools in 1998 to that in 2001?
Make the answer very short. 0.98. What is the ratio of the Gross enrolment ratio (%) of Pre-primary schools in 1998 to that in 2002?
Keep it short and to the point. 1.51. What is the ratio of the Gross enrolment ratio (%) of Primary schools in 1998 to that in 2002?
Keep it short and to the point. 0.8. What is the ratio of the Gross enrolment ratio (%) in Secondary schools in 1998 to that in 2002?
Keep it short and to the point. 0.62. What is the ratio of the Gross enrolment ratio (%) in Tertiary schools in 1998 to that in 2002?
Offer a terse response. 0.69. What is the ratio of the Gross enrolment ratio (%) in Pre-primary schools in 1999 to that in 2000?
Make the answer very short. 1.08. What is the ratio of the Gross enrolment ratio (%) of Primary schools in 1999 to that in 2000?
Offer a terse response. 1.07. What is the ratio of the Gross enrolment ratio (%) of Secondary schools in 1999 to that in 2000?
Offer a very short reply. 0.76. What is the ratio of the Gross enrolment ratio (%) of Tertiary schools in 1999 to that in 2000?
Keep it short and to the point. 0.84. What is the ratio of the Gross enrolment ratio (%) of Pre-primary schools in 1999 to that in 2001?
Provide a short and direct response. 1.15. What is the ratio of the Gross enrolment ratio (%) in Primary schools in 1999 to that in 2001?
Give a very brief answer. 0.98. What is the ratio of the Gross enrolment ratio (%) in Secondary schools in 1999 to that in 2001?
Provide a short and direct response. 1.1. What is the ratio of the Gross enrolment ratio (%) in Tertiary schools in 1999 to that in 2001?
Provide a succinct answer. 1.03. What is the ratio of the Gross enrolment ratio (%) in Pre-primary schools in 1999 to that in 2002?
Ensure brevity in your answer.  1.3. What is the ratio of the Gross enrolment ratio (%) of Primary schools in 1999 to that in 2002?
Keep it short and to the point. 0.95. What is the ratio of the Gross enrolment ratio (%) in Secondary schools in 1999 to that in 2002?
Provide a short and direct response. 0.58. What is the ratio of the Gross enrolment ratio (%) of Tertiary schools in 1999 to that in 2002?
Provide a succinct answer. 0.72. What is the ratio of the Gross enrolment ratio (%) in Pre-primary schools in 2000 to that in 2001?
Offer a terse response. 1.06. What is the ratio of the Gross enrolment ratio (%) in Primary schools in 2000 to that in 2001?
Your response must be concise. 0.91. What is the ratio of the Gross enrolment ratio (%) in Secondary schools in 2000 to that in 2001?
Provide a succinct answer. 1.45. What is the ratio of the Gross enrolment ratio (%) in Tertiary schools in 2000 to that in 2001?
Provide a short and direct response. 1.23. What is the ratio of the Gross enrolment ratio (%) in Pre-primary schools in 2000 to that in 2002?
Provide a short and direct response. 1.2. What is the ratio of the Gross enrolment ratio (%) in Primary schools in 2000 to that in 2002?
Offer a terse response. 0.89. What is the ratio of the Gross enrolment ratio (%) of Secondary schools in 2000 to that in 2002?
Make the answer very short. 0.76. What is the ratio of the Gross enrolment ratio (%) of Tertiary schools in 2000 to that in 2002?
Give a very brief answer. 0.86. What is the ratio of the Gross enrolment ratio (%) in Pre-primary schools in 2001 to that in 2002?
Provide a short and direct response. 1.13. What is the ratio of the Gross enrolment ratio (%) in Primary schools in 2001 to that in 2002?
Provide a short and direct response. 0.98. What is the ratio of the Gross enrolment ratio (%) of Secondary schools in 2001 to that in 2002?
Offer a terse response. 0.53. What is the ratio of the Gross enrolment ratio (%) in Tertiary schools in 2001 to that in 2002?
Offer a terse response. 0.7. What is the difference between the highest and the second highest Gross enrolment ratio (%) in Pre-primary schools?
Offer a terse response. 46.86. What is the difference between the highest and the second highest Gross enrolment ratio (%) in Primary schools?
Make the answer very short. 1.37. What is the difference between the highest and the second highest Gross enrolment ratio (%) in Secondary schools?
Your answer should be compact. 2.84. What is the difference between the highest and the second highest Gross enrolment ratio (%) in Tertiary schools?
Offer a very short reply. 0.13. What is the difference between the highest and the lowest Gross enrolment ratio (%) in Pre-primary schools?
Make the answer very short. 54.21. What is the difference between the highest and the lowest Gross enrolment ratio (%) of Primary schools?
Give a very brief answer. 22.95. What is the difference between the highest and the lowest Gross enrolment ratio (%) in Secondary schools?
Give a very brief answer. 5.69. What is the difference between the highest and the lowest Gross enrolment ratio (%) of Tertiary schools?
Provide a succinct answer. 0.43. 